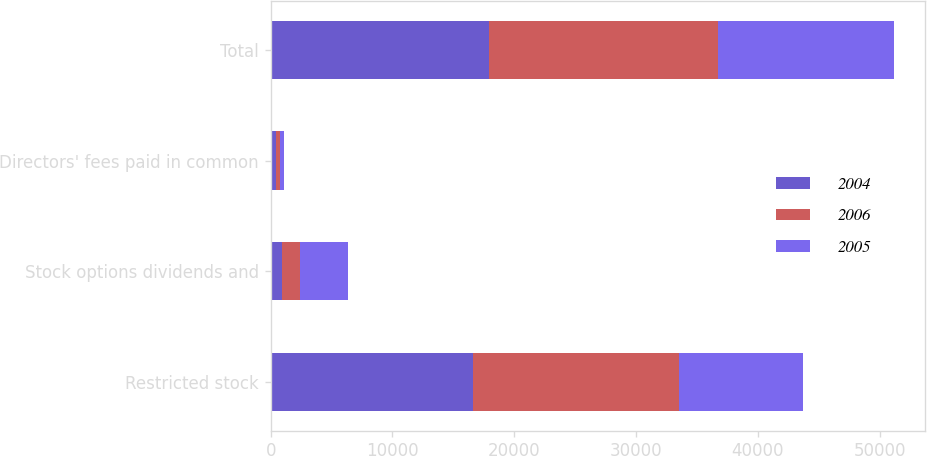Convert chart to OTSL. <chart><loc_0><loc_0><loc_500><loc_500><stacked_bar_chart><ecel><fcel>Restricted stock<fcel>Stock options dividends and<fcel>Directors' fees paid in common<fcel>Total<nl><fcel>2004<fcel>16584<fcel>960<fcel>406<fcel>17950<nl><fcel>2006<fcel>16955<fcel>1440<fcel>360<fcel>18755<nl><fcel>2005<fcel>10154<fcel>3928<fcel>343<fcel>14425<nl></chart> 